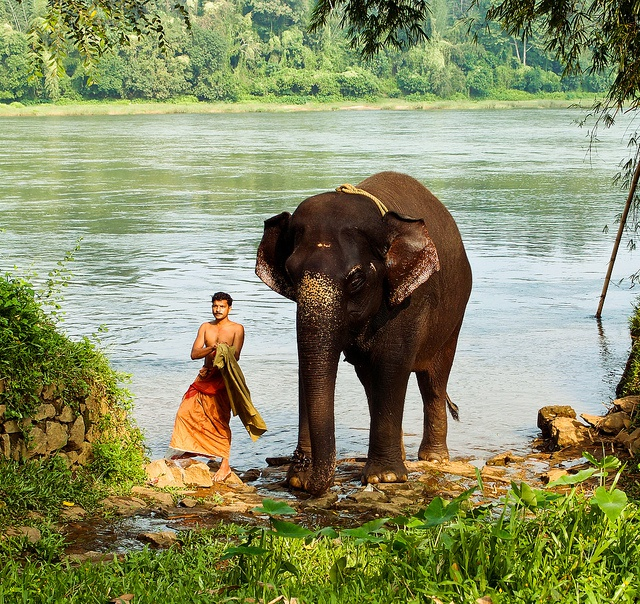Describe the objects in this image and their specific colors. I can see elephant in lightgreen, black, maroon, and brown tones and people in lightgreen, orange, black, and maroon tones in this image. 